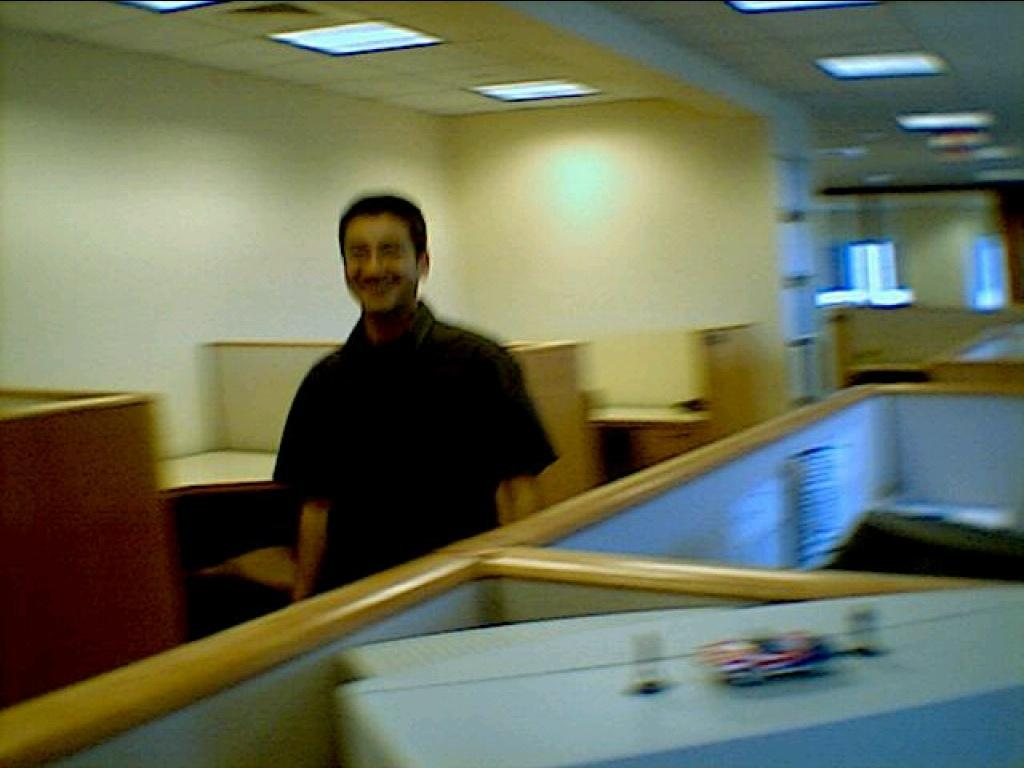Who is the main subject in the image? There is a man in the center of the image. What is the man wearing? The man is wearing a shirt. What can be seen in the background of the image? There is a wall and a window in the background of the image. What is visible at the top of the image? There are lights visible at the top of the image. How many beds are visible in the image? There are no beds present in the image. What type of print is on the man's shirt? The man's shirt does not have any visible print; only the color of the shirt is mentioned. 